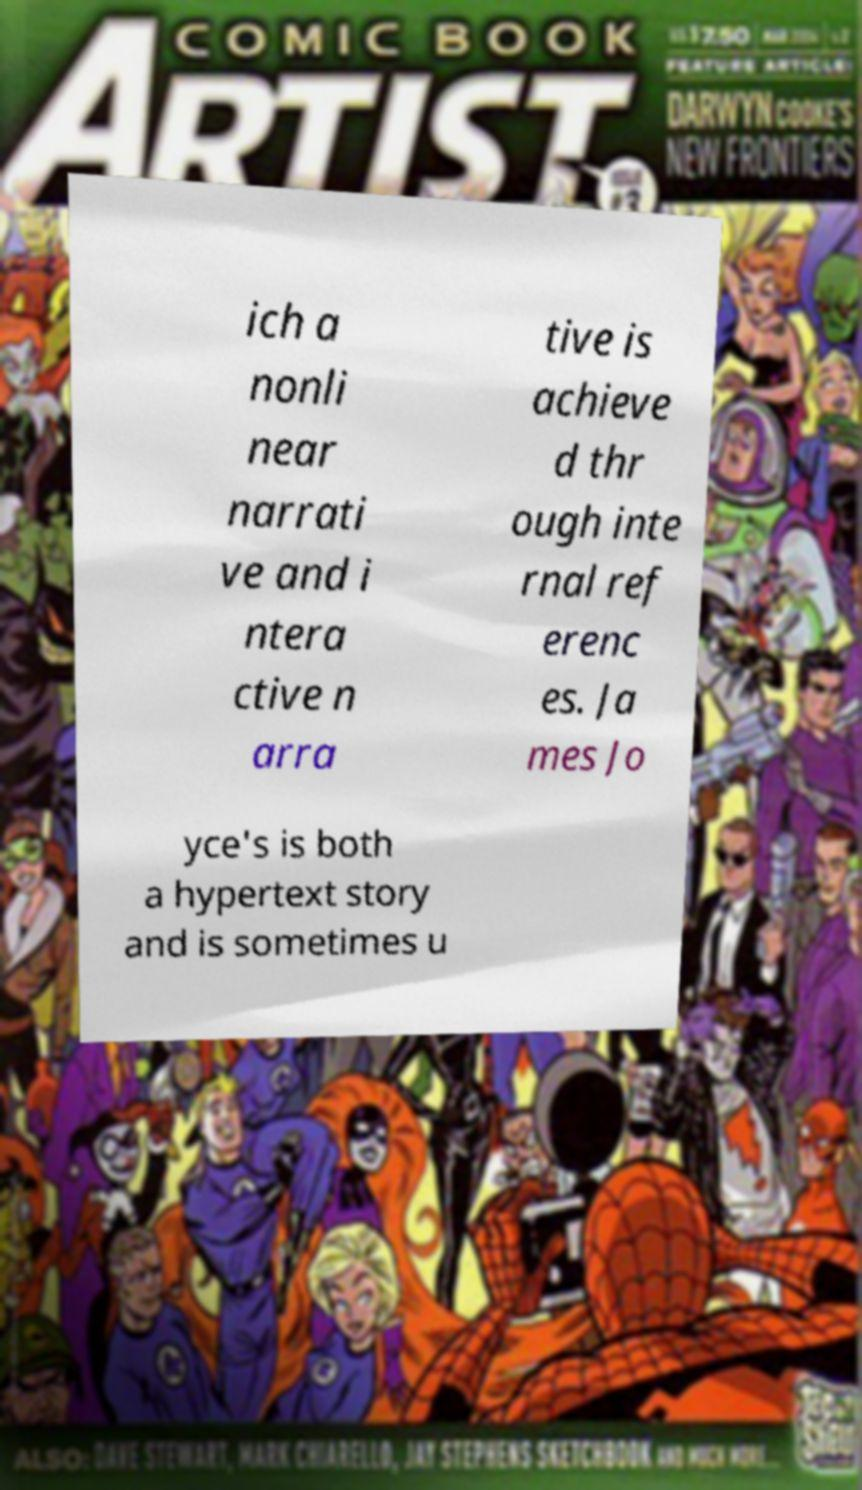Can you accurately transcribe the text from the provided image for me? ich a nonli near narrati ve and i ntera ctive n arra tive is achieve d thr ough inte rnal ref erenc es. Ja mes Jo yce's is both a hypertext story and is sometimes u 